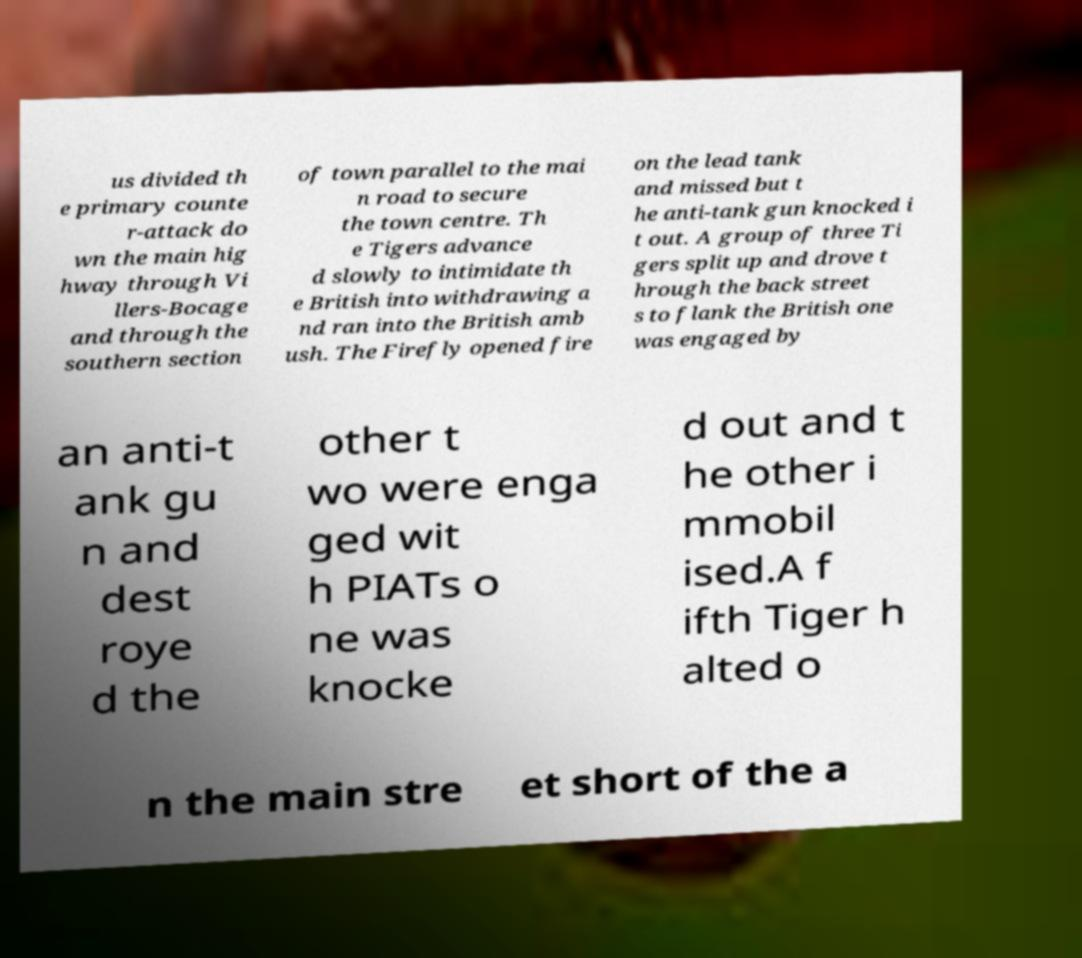Could you extract and type out the text from this image? us divided th e primary counte r-attack do wn the main hig hway through Vi llers-Bocage and through the southern section of town parallel to the mai n road to secure the town centre. Th e Tigers advance d slowly to intimidate th e British into withdrawing a nd ran into the British amb ush. The Firefly opened fire on the lead tank and missed but t he anti-tank gun knocked i t out. A group of three Ti gers split up and drove t hrough the back street s to flank the British one was engaged by an anti-t ank gu n and dest roye d the other t wo were enga ged wit h PIATs o ne was knocke d out and t he other i mmobil ised.A f ifth Tiger h alted o n the main stre et short of the a 